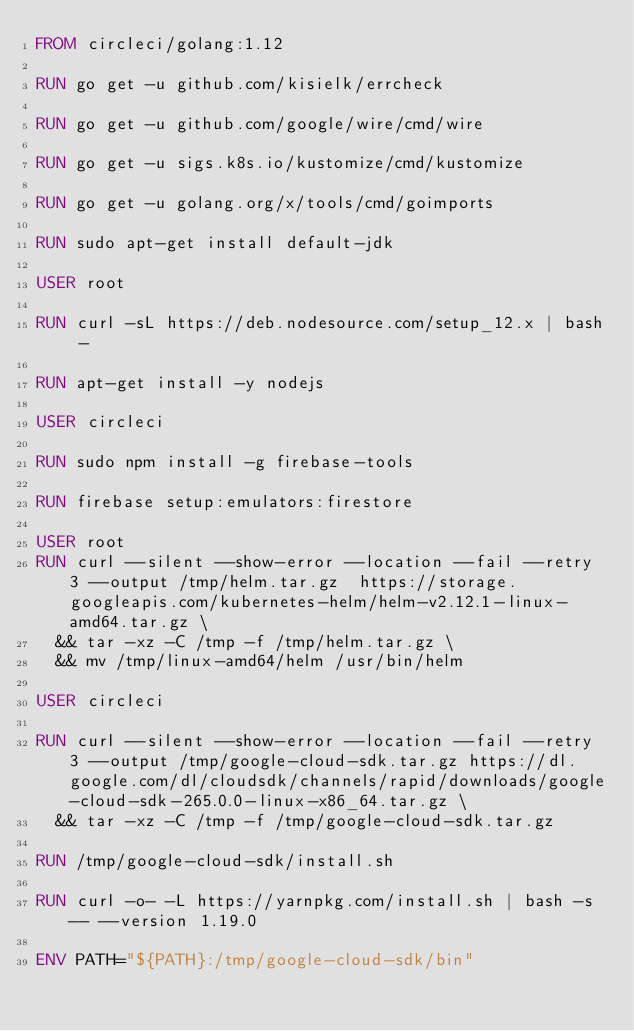Convert code to text. <code><loc_0><loc_0><loc_500><loc_500><_Dockerfile_>FROM circleci/golang:1.12

RUN go get -u github.com/kisielk/errcheck

RUN go get -u github.com/google/wire/cmd/wire

RUN go get -u sigs.k8s.io/kustomize/cmd/kustomize

RUN go get -u golang.org/x/tools/cmd/goimports

RUN sudo apt-get install default-jdk

USER root

RUN curl -sL https://deb.nodesource.com/setup_12.x | bash -

RUN apt-get install -y nodejs

USER circleci

RUN sudo npm install -g firebase-tools

RUN firebase setup:emulators:firestore

USER root
RUN curl --silent --show-error --location --fail --retry 3 --output /tmp/helm.tar.gz  https://storage.googleapis.com/kubernetes-helm/helm-v2.12.1-linux-amd64.tar.gz \
  && tar -xz -C /tmp -f /tmp/helm.tar.gz \
  && mv /tmp/linux-amd64/helm /usr/bin/helm

USER circleci

RUN curl --silent --show-error --location --fail --retry 3 --output /tmp/google-cloud-sdk.tar.gz https://dl.google.com/dl/cloudsdk/channels/rapid/downloads/google-cloud-sdk-265.0.0-linux-x86_64.tar.gz \
  && tar -xz -C /tmp -f /tmp/google-cloud-sdk.tar.gz

RUN /tmp/google-cloud-sdk/install.sh

RUN curl -o- -L https://yarnpkg.com/install.sh | bash -s -- --version 1.19.0

ENV PATH="${PATH}:/tmp/google-cloud-sdk/bin"</code> 